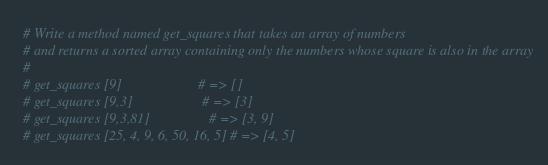<code> <loc_0><loc_0><loc_500><loc_500><_Ruby_># Write a method named get_squares that takes an array of numbers
# and returns a sorted array containing only the numbers whose square is also in the array
# 
# get_squares [9]                      # => []
# get_squares [9,3]                    # => [3]
# get_squares [9,3,81]                 # => [3, 9]
# get_squares [25, 4, 9, 6, 50, 16, 5] # => [4, 5]
</code> 